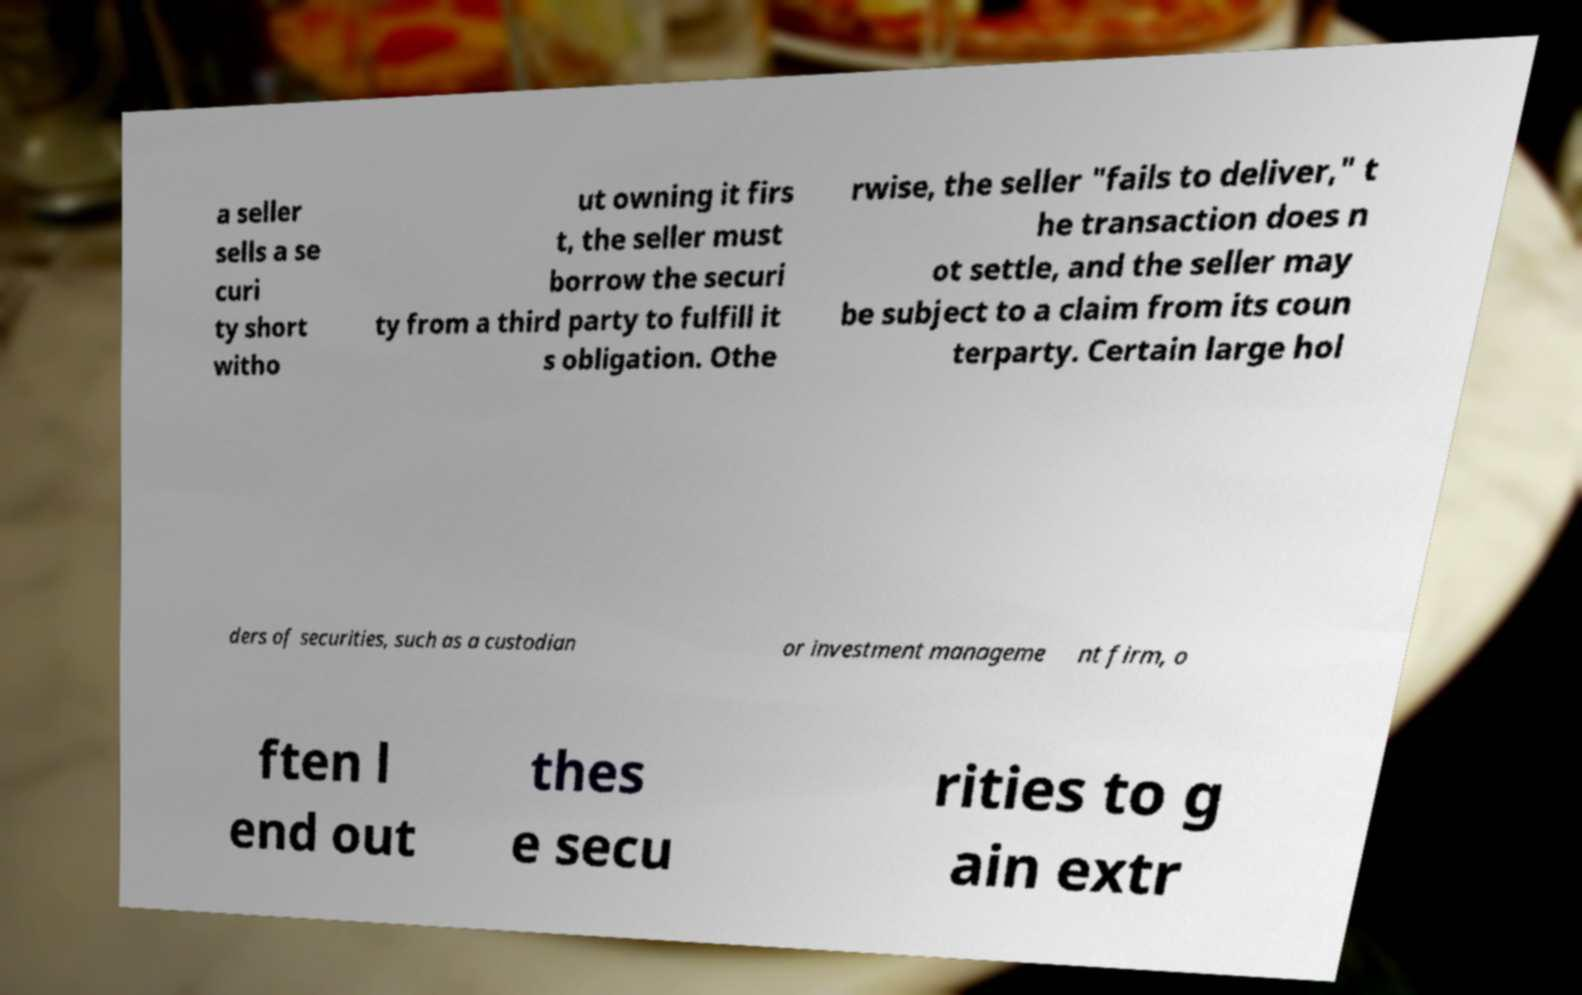Could you extract and type out the text from this image? a seller sells a se curi ty short witho ut owning it firs t, the seller must borrow the securi ty from a third party to fulfill it s obligation. Othe rwise, the seller "fails to deliver," t he transaction does n ot settle, and the seller may be subject to a claim from its coun terparty. Certain large hol ders of securities, such as a custodian or investment manageme nt firm, o ften l end out thes e secu rities to g ain extr 